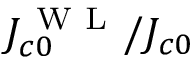<formula> <loc_0><loc_0><loc_500><loc_500>J _ { c 0 } ^ { W L } / J _ { c 0 }</formula> 